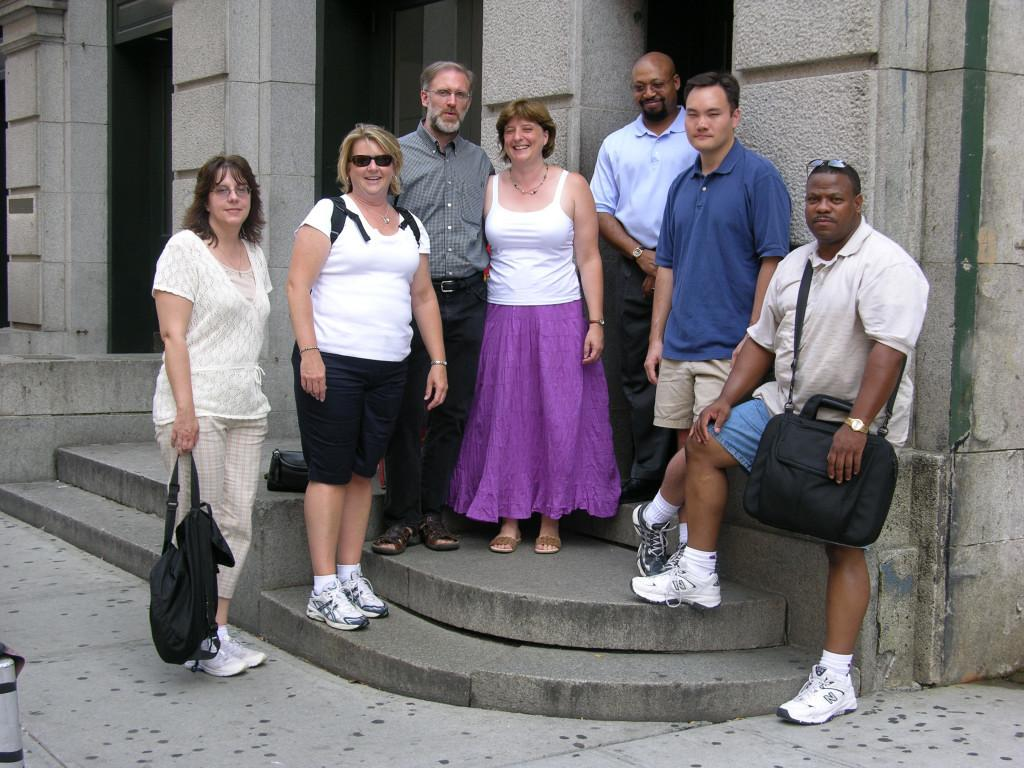How many people are in the image? There are persons in the image, but the exact number is not specified. What is the facial expression of the persons in the image? The persons in the image are smiling. What position are the persons in the image? The persons are standing. What can be seen in the background of the image? There is a building in the background of the image. What object is on the left side of the image? There is a small pole on the left side of the image. What type of fiction is the worm reading in the image? There is no worm or fiction present in the image. What type of shoes are the persons wearing in the image? The provided facts do not mention the type of shoes the persons are wearing in the image. 